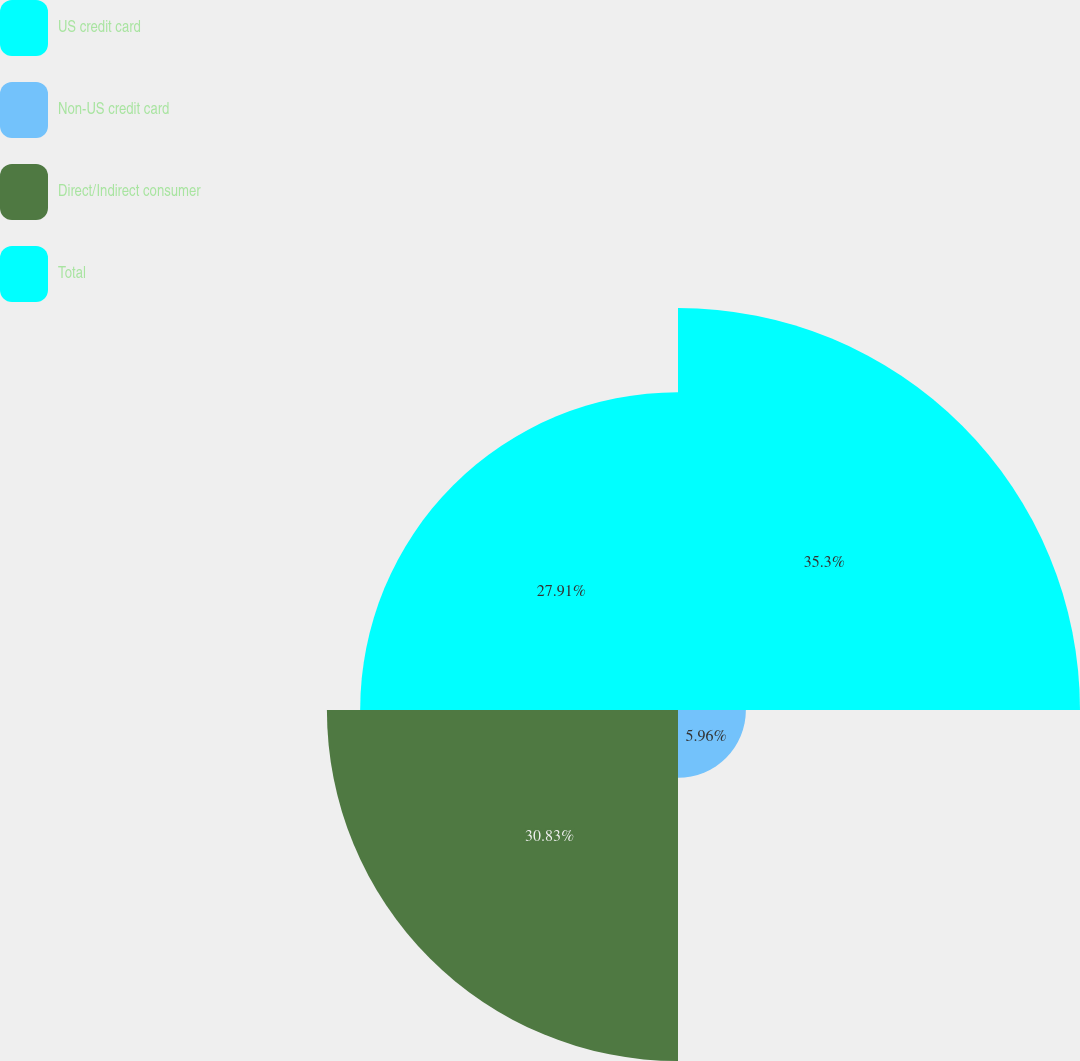Convert chart. <chart><loc_0><loc_0><loc_500><loc_500><pie_chart><fcel>US credit card<fcel>Non-US credit card<fcel>Direct/Indirect consumer<fcel>Total<nl><fcel>35.3%<fcel>5.96%<fcel>30.83%<fcel>27.91%<nl></chart> 